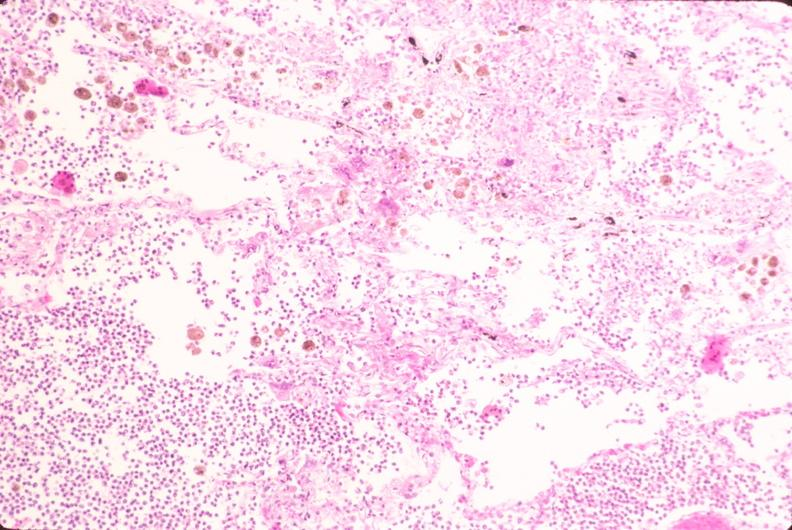what is present?
Answer the question using a single word or phrase. Respiratory 